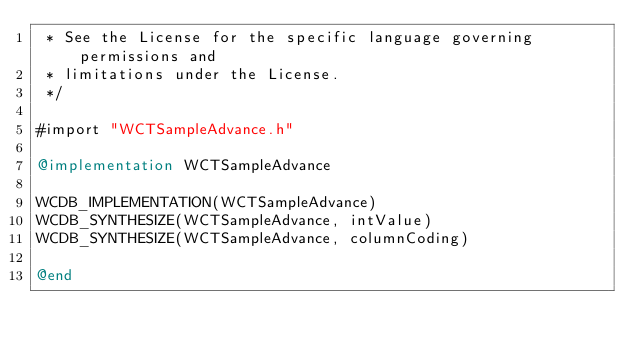<code> <loc_0><loc_0><loc_500><loc_500><_ObjectiveC_> * See the License for the specific language governing permissions and
 * limitations under the License.
 */

#import "WCTSampleAdvance.h"

@implementation WCTSampleAdvance

WCDB_IMPLEMENTATION(WCTSampleAdvance)
WCDB_SYNTHESIZE(WCTSampleAdvance, intValue)
WCDB_SYNTHESIZE(WCTSampleAdvance, columnCoding)

@end
</code> 